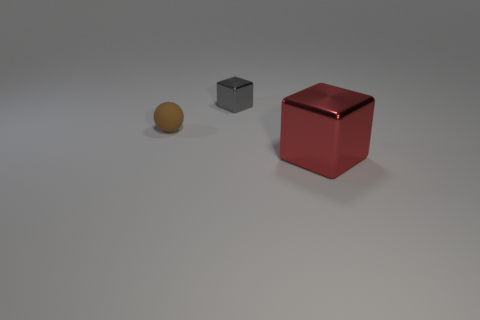Add 2 big red matte cylinders. How many objects exist? 5 Subtract all cubes. How many objects are left? 1 Subtract all big cyan metal things. Subtract all large blocks. How many objects are left? 2 Add 1 tiny gray shiny blocks. How many tiny gray shiny blocks are left? 2 Add 3 tiny blue matte objects. How many tiny blue matte objects exist? 3 Subtract 0 green blocks. How many objects are left? 3 